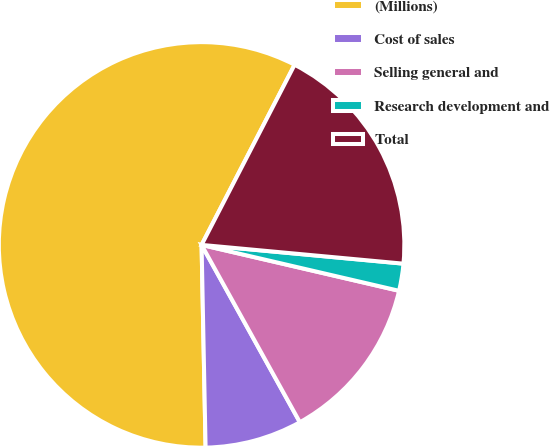<chart> <loc_0><loc_0><loc_500><loc_500><pie_chart><fcel>(Millions)<fcel>Cost of sales<fcel>Selling general and<fcel>Research development and<fcel>Total<nl><fcel>57.9%<fcel>7.74%<fcel>13.31%<fcel>2.16%<fcel>18.89%<nl></chart> 